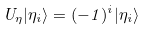Convert formula to latex. <formula><loc_0><loc_0><loc_500><loc_500>U _ { \eta } | \eta _ { i } \rangle = ( - 1 ) ^ { i } | \eta _ { i } \rangle</formula> 